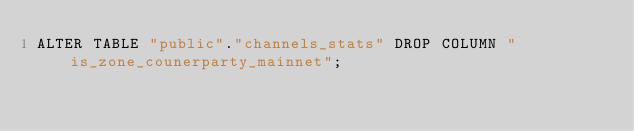Convert code to text. <code><loc_0><loc_0><loc_500><loc_500><_SQL_>ALTER TABLE "public"."channels_stats" DROP COLUMN "is_zone_counerparty_mainnet";
</code> 